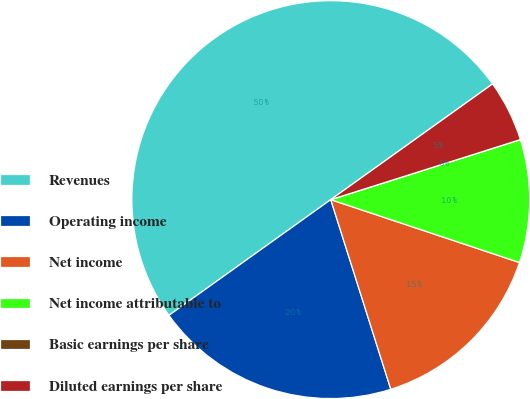Convert chart to OTSL. <chart><loc_0><loc_0><loc_500><loc_500><pie_chart><fcel>Revenues<fcel>Operating income<fcel>Net income<fcel>Net income attributable to<fcel>Basic earnings per share<fcel>Diluted earnings per share<nl><fcel>50.0%<fcel>20.0%<fcel>15.0%<fcel>10.0%<fcel>0.0%<fcel>5.0%<nl></chart> 